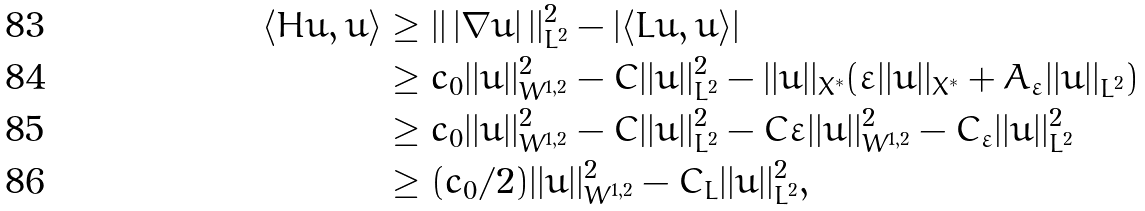<formula> <loc_0><loc_0><loc_500><loc_500>\langle H u , u \rangle & \geq | | \, | \nabla u | \, | | _ { L ^ { 2 } } ^ { 2 } - | \langle L u , u \rangle | \\ & \geq c _ { 0 } | | u | | _ { W ^ { 1 , 2 } } ^ { 2 } - C | | u | | _ { L ^ { 2 } } ^ { 2 } - | | u | | _ { X ^ { \ast } } ( \varepsilon | | u | | _ { X ^ { \ast } } + A _ { \varepsilon } | | u | | _ { L ^ { 2 } } ) \\ & \geq c _ { 0 } | | u | | _ { W ^ { 1 , 2 } } ^ { 2 } - C | | u | | _ { L ^ { 2 } } ^ { 2 } - C \varepsilon | | u | | _ { W ^ { 1 , 2 } } ^ { 2 } - C _ { \varepsilon } | | u | | _ { L ^ { 2 } } ^ { 2 } \\ & \geq ( c _ { 0 } / 2 ) | | u | | _ { W ^ { 1 , 2 } } ^ { 2 } - C _ { L } | | u | | _ { L ^ { 2 } } ^ { 2 } ,</formula> 